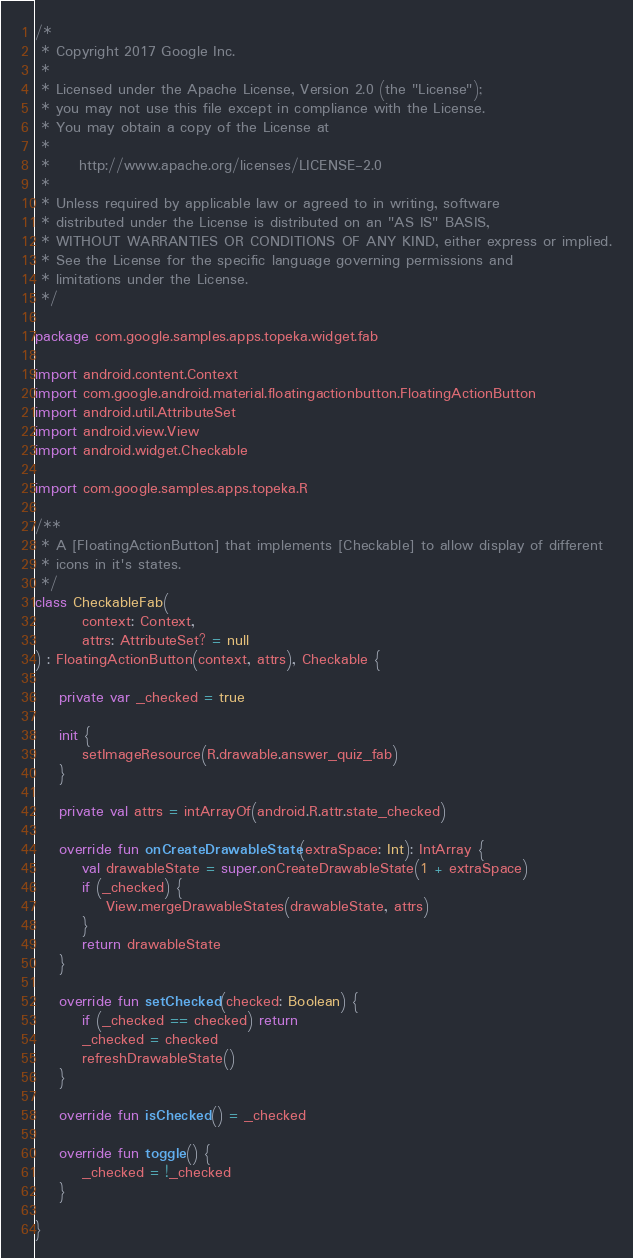Convert code to text. <code><loc_0><loc_0><loc_500><loc_500><_Kotlin_>/*
 * Copyright 2017 Google Inc.
 *
 * Licensed under the Apache License, Version 2.0 (the "License");
 * you may not use this file except in compliance with the License.
 * You may obtain a copy of the License at
 *
 *     http://www.apache.org/licenses/LICENSE-2.0
 *
 * Unless required by applicable law or agreed to in writing, software
 * distributed under the License is distributed on an "AS IS" BASIS,
 * WITHOUT WARRANTIES OR CONDITIONS OF ANY KIND, either express or implied.
 * See the License for the specific language governing permissions and
 * limitations under the License.
 */

package com.google.samples.apps.topeka.widget.fab

import android.content.Context
import com.google.android.material.floatingactionbutton.FloatingActionButton
import android.util.AttributeSet
import android.view.View
import android.widget.Checkable

import com.google.samples.apps.topeka.R

/**
 * A [FloatingActionButton] that implements [Checkable] to allow display of different
 * icons in it's states.
 */
class CheckableFab(
        context: Context,
        attrs: AttributeSet? = null
) : FloatingActionButton(context, attrs), Checkable {

    private var _checked = true

    init {
        setImageResource(R.drawable.answer_quiz_fab)
    }

    private val attrs = intArrayOf(android.R.attr.state_checked)

    override fun onCreateDrawableState(extraSpace: Int): IntArray {
        val drawableState = super.onCreateDrawableState(1 + extraSpace)
        if (_checked) {
            View.mergeDrawableStates(drawableState, attrs)
        }
        return drawableState
    }

    override fun setChecked(checked: Boolean) {
        if (_checked == checked) return
        _checked = checked
        refreshDrawableState()
    }

    override fun isChecked() = _checked

    override fun toggle() {
        _checked = !_checked
    }

}
</code> 